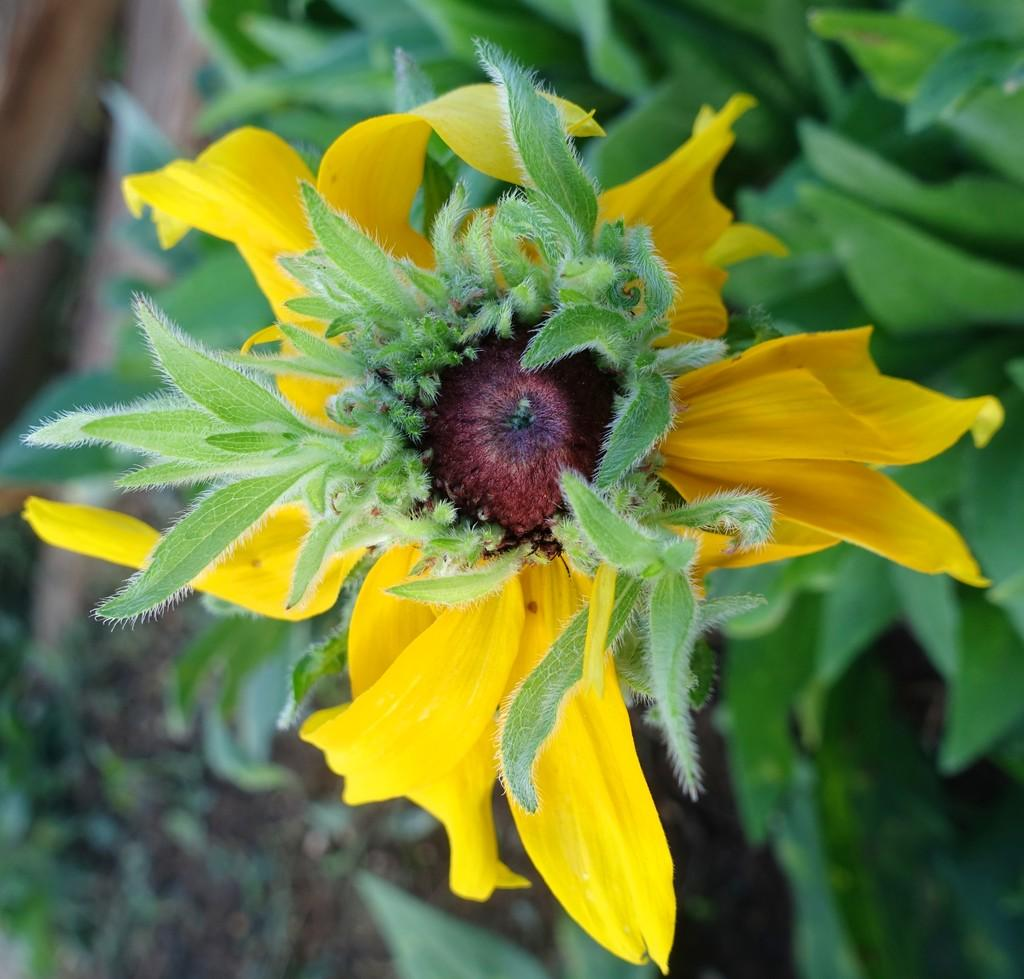What type of flower is in the picture? There is a yellow flower in the picture. What color are the petals of the flower? The flower has yellow petals. Does the flower have any other parts besides petals? Yes, the flower has leaves. What is the color of the backdrop in the image? The backdrop of the image is dark. What type of bun is visible in the image? There is no bun present in the image; it features a yellow flower with leaves. Can you tell me which letter is written on the petals of the flower? There is no letter written on the petals of the flower; they are simply yellow in color. 